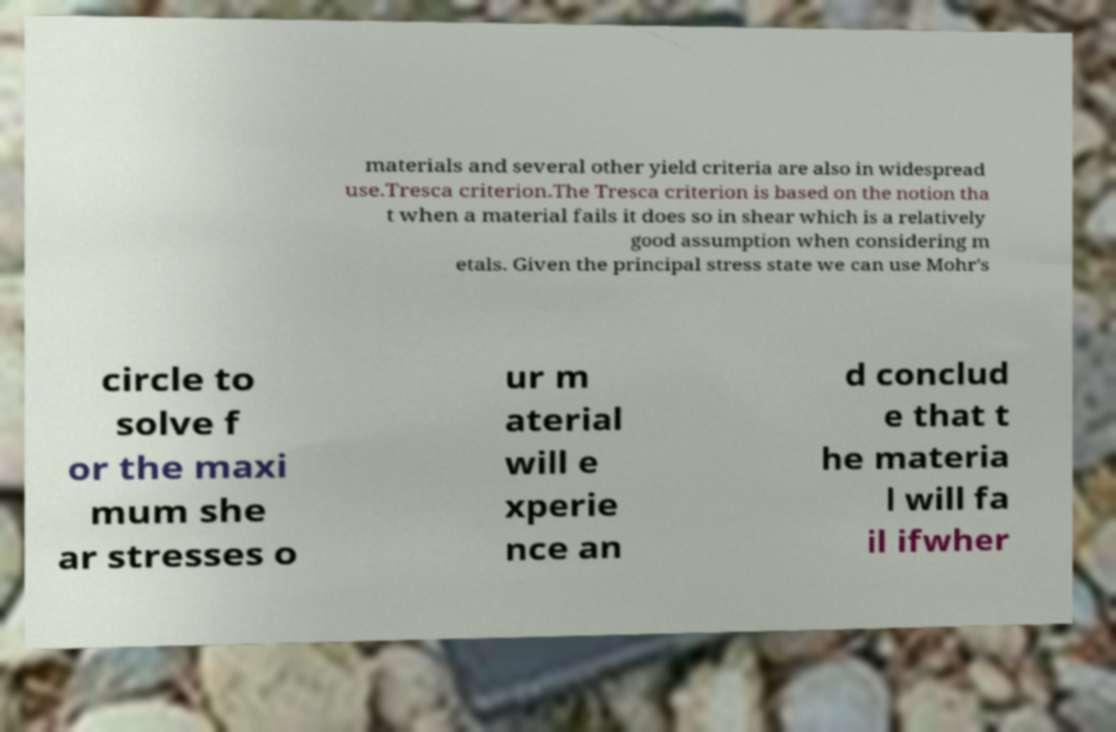Please identify and transcribe the text found in this image. materials and several other yield criteria are also in widespread use.Tresca criterion.The Tresca criterion is based on the notion tha t when a material fails it does so in shear which is a relatively good assumption when considering m etals. Given the principal stress state we can use Mohr's circle to solve f or the maxi mum she ar stresses o ur m aterial will e xperie nce an d conclud e that t he materia l will fa il ifwher 